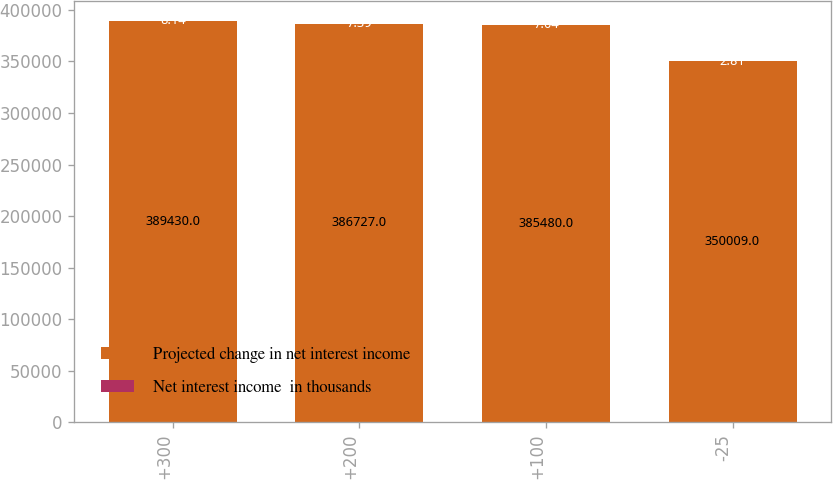Convert chart to OTSL. <chart><loc_0><loc_0><loc_500><loc_500><stacked_bar_chart><ecel><fcel>+300<fcel>+200<fcel>+100<fcel>-25<nl><fcel>Projected change in net interest income<fcel>389430<fcel>386727<fcel>385480<fcel>350009<nl><fcel>Net interest income  in thousands<fcel>8.14<fcel>7.39<fcel>7.04<fcel>2.81<nl></chart> 